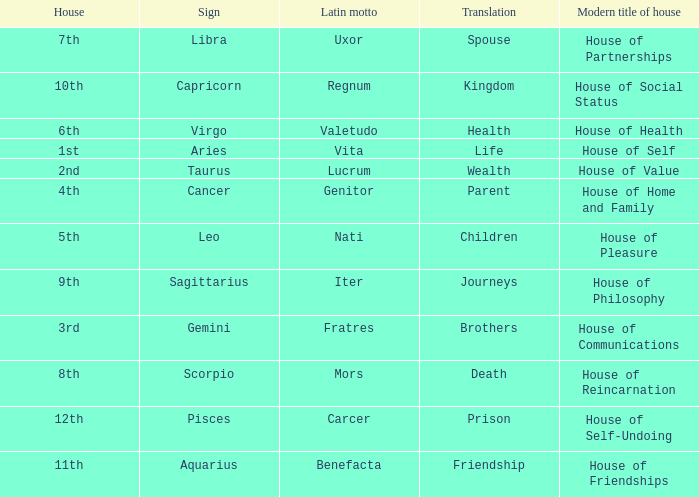Which astrological sign has the Latin motto of Vita? Aries. Would you be able to parse every entry in this table? {'header': ['House', 'Sign', 'Latin motto', 'Translation', 'Modern title of house'], 'rows': [['7th', 'Libra', 'Uxor', 'Spouse', 'House of Partnerships'], ['10th', 'Capricorn', 'Regnum', 'Kingdom', 'House of Social Status'], ['6th', 'Virgo', 'Valetudo', 'Health', 'House of Health'], ['1st', 'Aries', 'Vita', 'Life', 'House of Self'], ['2nd', 'Taurus', 'Lucrum', 'Wealth', 'House of Value'], ['4th', 'Cancer', 'Genitor', 'Parent', 'House of Home and Family'], ['5th', 'Leo', 'Nati', 'Children', 'House of Pleasure'], ['9th', 'Sagittarius', 'Iter', 'Journeys', 'House of Philosophy'], ['3rd', 'Gemini', 'Fratres', 'Brothers', 'House of Communications'], ['8th', 'Scorpio', 'Mors', 'Death', 'House of Reincarnation'], ['12th', 'Pisces', 'Carcer', 'Prison', 'House of Self-Undoing'], ['11th', 'Aquarius', 'Benefacta', 'Friendship', 'House of Friendships']]} 